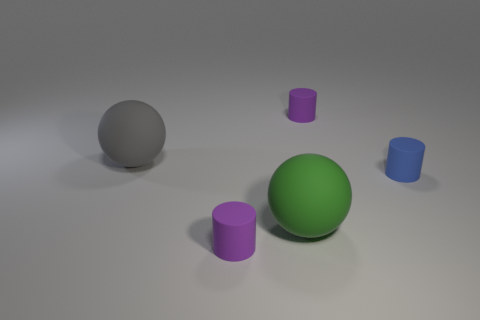The green thing that is the same material as the blue thing is what size?
Your response must be concise. Large. There is a tiny purple matte cylinder behind the large object that is in front of the big gray sphere; how many matte things are left of it?
Ensure brevity in your answer.  3. There is a purple cylinder that is in front of the sphere in front of the ball that is behind the blue cylinder; what is it made of?
Give a very brief answer. Rubber. Does the tiny purple rubber object that is behind the green rubber object have the same shape as the tiny blue object?
Make the answer very short. Yes. There is a big ball in front of the gray ball; what is its material?
Offer a terse response. Rubber. Are there any other objects that have the same size as the gray rubber object?
Offer a terse response. Yes. There is a sphere that is in front of the blue cylinder; what is its size?
Your answer should be compact. Large. What is the material of the green thing that is the same shape as the gray rubber thing?
Your answer should be very brief. Rubber. Are there the same number of blue rubber cylinders that are in front of the green sphere and big purple metallic cubes?
Ensure brevity in your answer.  Yes. What is the size of the rubber thing that is behind the large green matte object and left of the green matte sphere?
Keep it short and to the point. Large. 